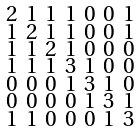Convert formula to latex. <formula><loc_0><loc_0><loc_500><loc_500>\begin{smallmatrix} 2 & 1 & 1 & 1 & 0 & 0 & 1 \\ 1 & 2 & 1 & 1 & 0 & 0 & 1 \\ 1 & 1 & 2 & 1 & 0 & 0 & 0 \\ 1 & 1 & 1 & 3 & 1 & 0 & 0 \\ 0 & 0 & 0 & 1 & 3 & 1 & 0 \\ 0 & 0 & 0 & 0 & 1 & 3 & 1 \\ 1 & 1 & 0 & 0 & 0 & 1 & 3 \end{smallmatrix}</formula> 